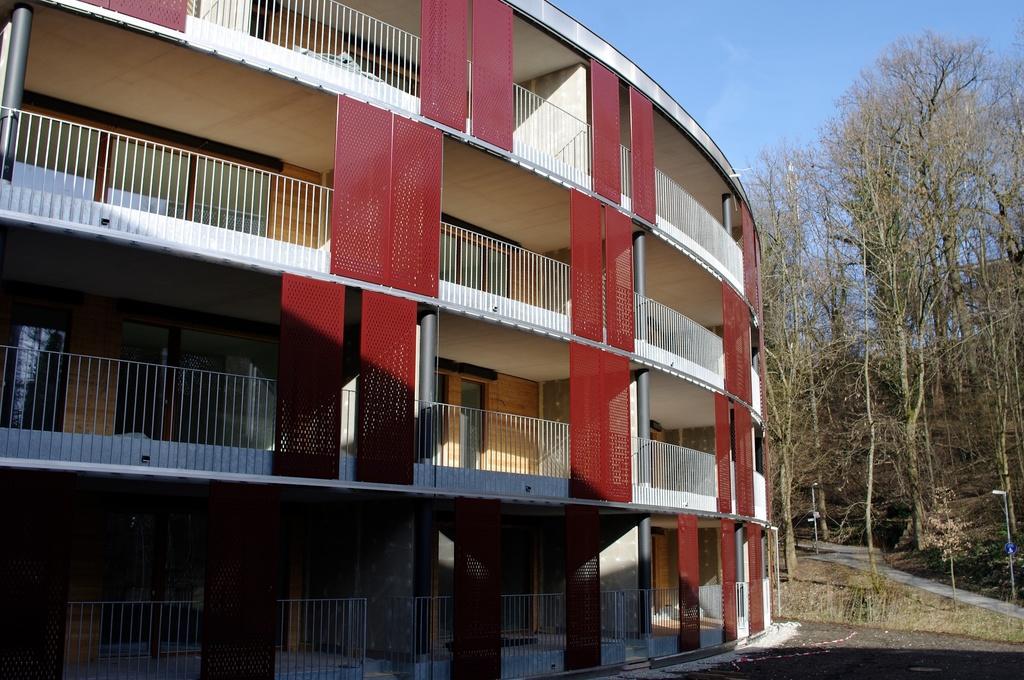Please provide a concise description of this image. This is a building with the pillars and the iron grills. These are the trees. This looks like a pathway. Here is the sky. 